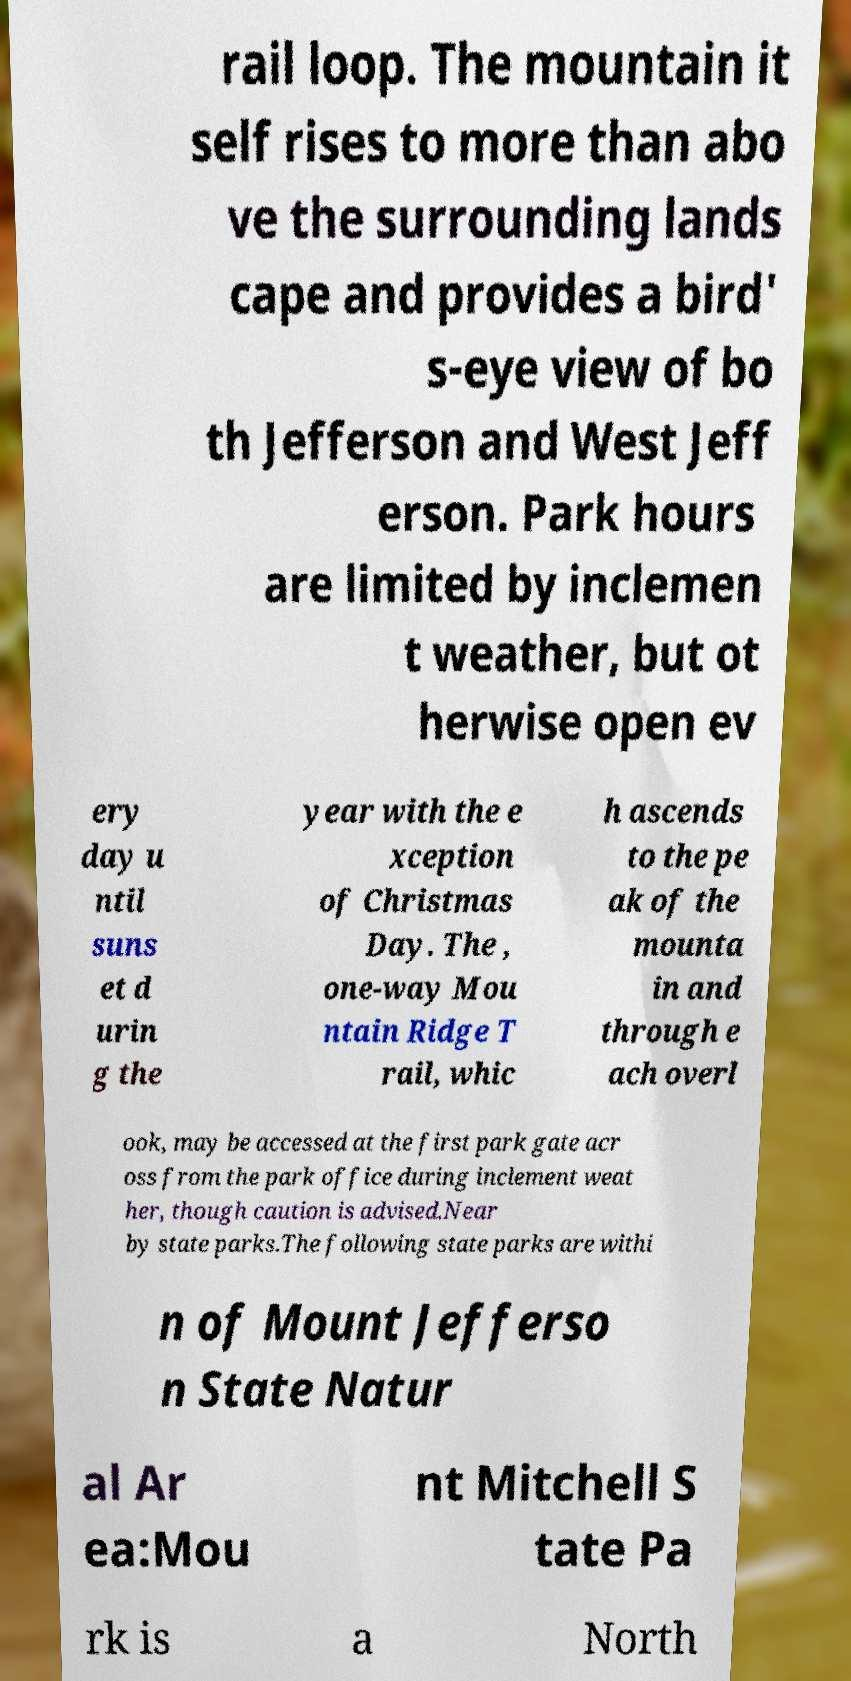Could you assist in decoding the text presented in this image and type it out clearly? rail loop. The mountain it self rises to more than abo ve the surrounding lands cape and provides a bird' s-eye view of bo th Jefferson and West Jeff erson. Park hours are limited by inclemen t weather, but ot herwise open ev ery day u ntil suns et d urin g the year with the e xception of Christmas Day. The , one-way Mou ntain Ridge T rail, whic h ascends to the pe ak of the mounta in and through e ach overl ook, may be accessed at the first park gate acr oss from the park office during inclement weat her, though caution is advised.Near by state parks.The following state parks are withi n of Mount Jefferso n State Natur al Ar ea:Mou nt Mitchell S tate Pa rk is a North 